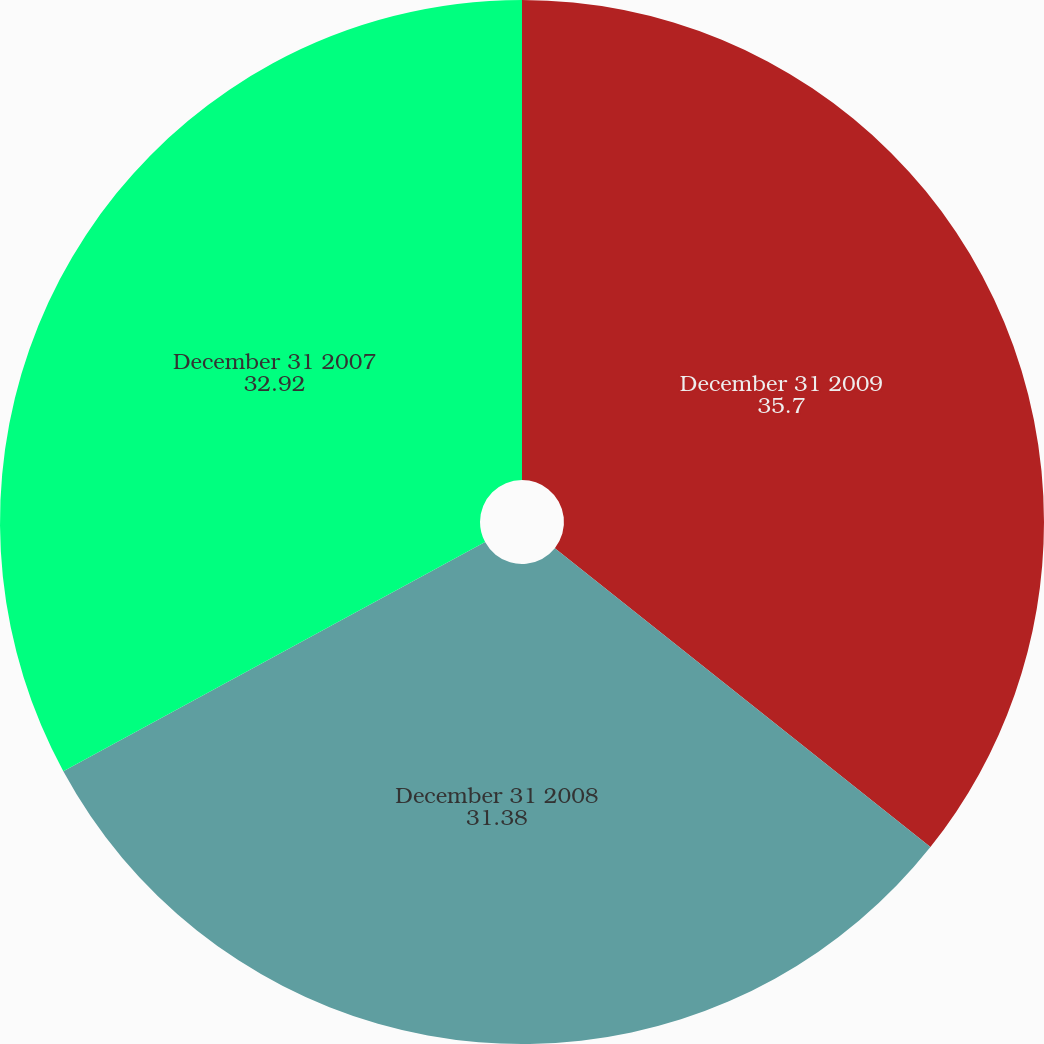<chart> <loc_0><loc_0><loc_500><loc_500><pie_chart><fcel>December 31 2009<fcel>December 31 2008<fcel>December 31 2007<nl><fcel>35.7%<fcel>31.38%<fcel>32.92%<nl></chart> 